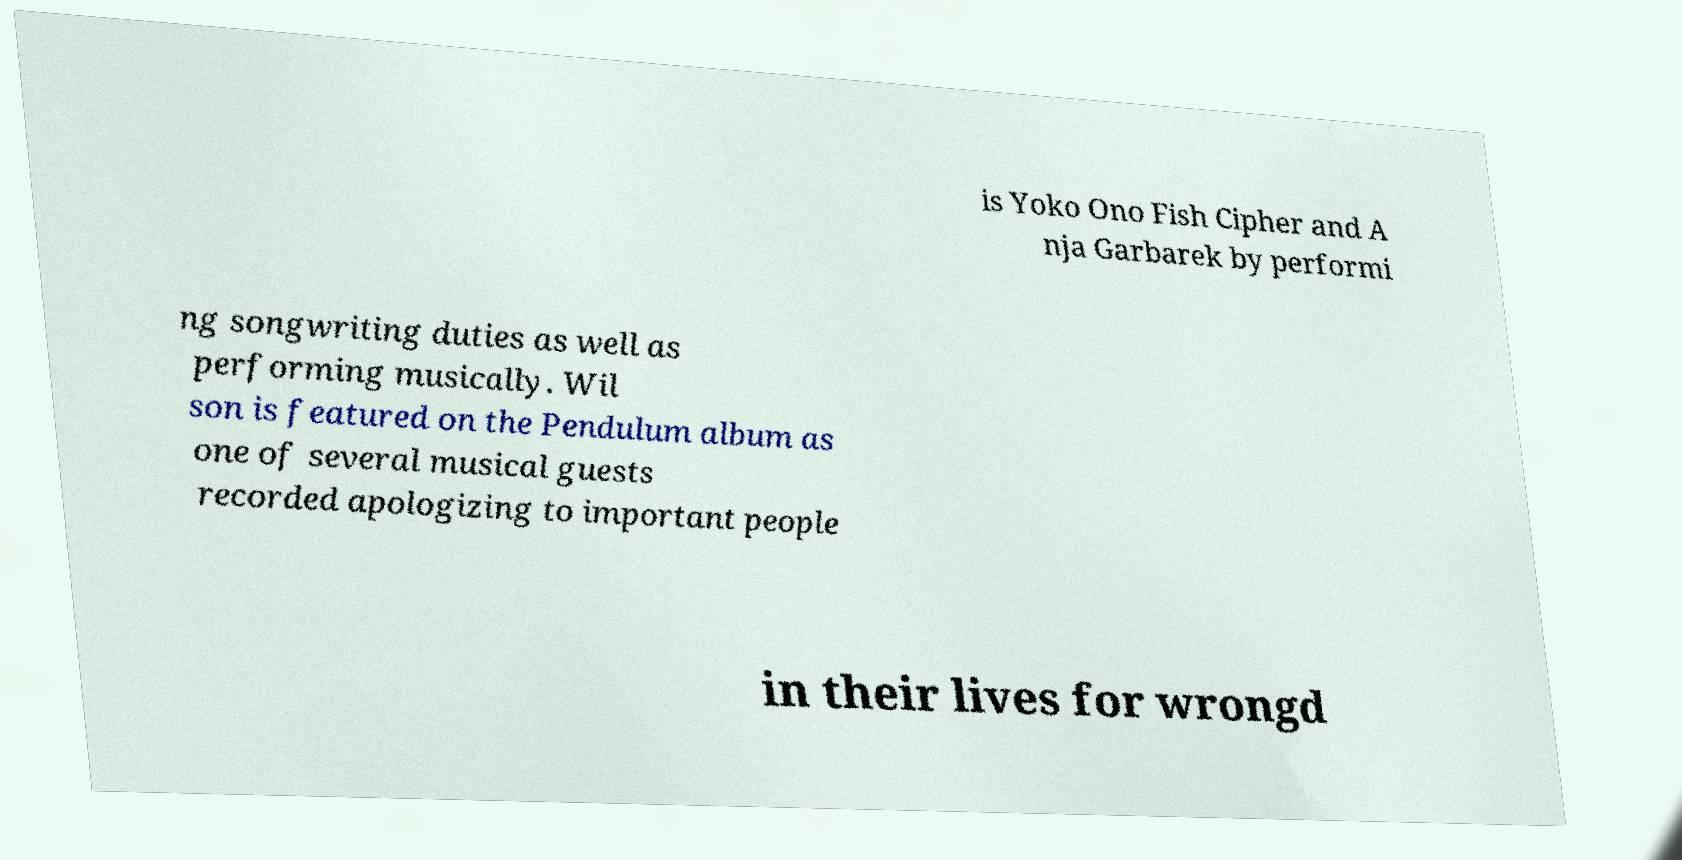For documentation purposes, I need the text within this image transcribed. Could you provide that? is Yoko Ono Fish Cipher and A nja Garbarek by performi ng songwriting duties as well as performing musically. Wil son is featured on the Pendulum album as one of several musical guests recorded apologizing to important people in their lives for wrongd 